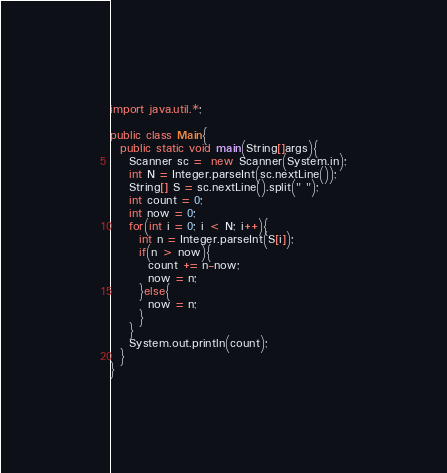<code> <loc_0><loc_0><loc_500><loc_500><_Java_>import java.util.*;
 
public class Main{
  public static void main(String[]args){
    Scanner sc =  new Scanner(System.in);
    int N = Integer.parseInt(sc.nextLine());
    String[] S = sc.nextLine().split(" ");
    int count = 0;
    int now = 0;
    for(int i = 0; i < N; i++){
      int n = Integer.parseInt(S[i]);
      if(n > now){
        count += n-now;
        now = n;
      }else{
        now = n;
      }
    }
    System.out.println(count);
  }
}</code> 